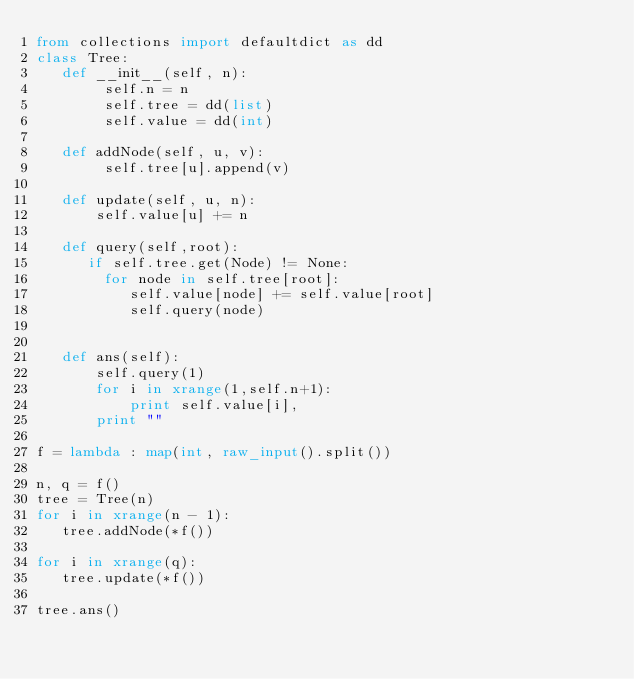Convert code to text. <code><loc_0><loc_0><loc_500><loc_500><_Python_>from collections import defaultdict as dd
class Tree:
   def __init__(self, n):
        self.n = n
        self.tree = dd(list)
        self.value = dd(int)
    
   def addNode(self, u, v):
        self.tree[u].append(v)
    
   def update(self, u, n):
       self.value[u] += n
   
   def query(self,root):
      if self.tree.get(Node) != None:
        for node in self.tree[root]:
           self.value[node] += self.value[root]
           self.query(node)

   
   def ans(self):
       self.query(1)
       for i in xrange(1,self.n+1):
           print self.value[i],
       print ""

f = lambda : map(int, raw_input().split())

n, q = f()
tree = Tree(n)
for i in xrange(n - 1):
   tree.addNode(*f())
   
for i in xrange(q):
   tree.update(*f())

tree.ans()
           </code> 